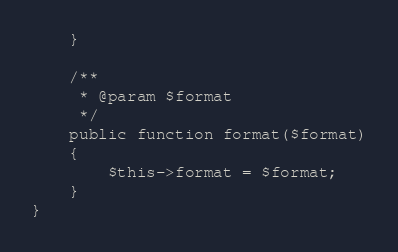Convert code to text. <code><loc_0><loc_0><loc_500><loc_500><_PHP_>    }

    /**
     * @param $format
     */
    public function format($format)
    {
        $this->format = $format;
    }
}</code> 